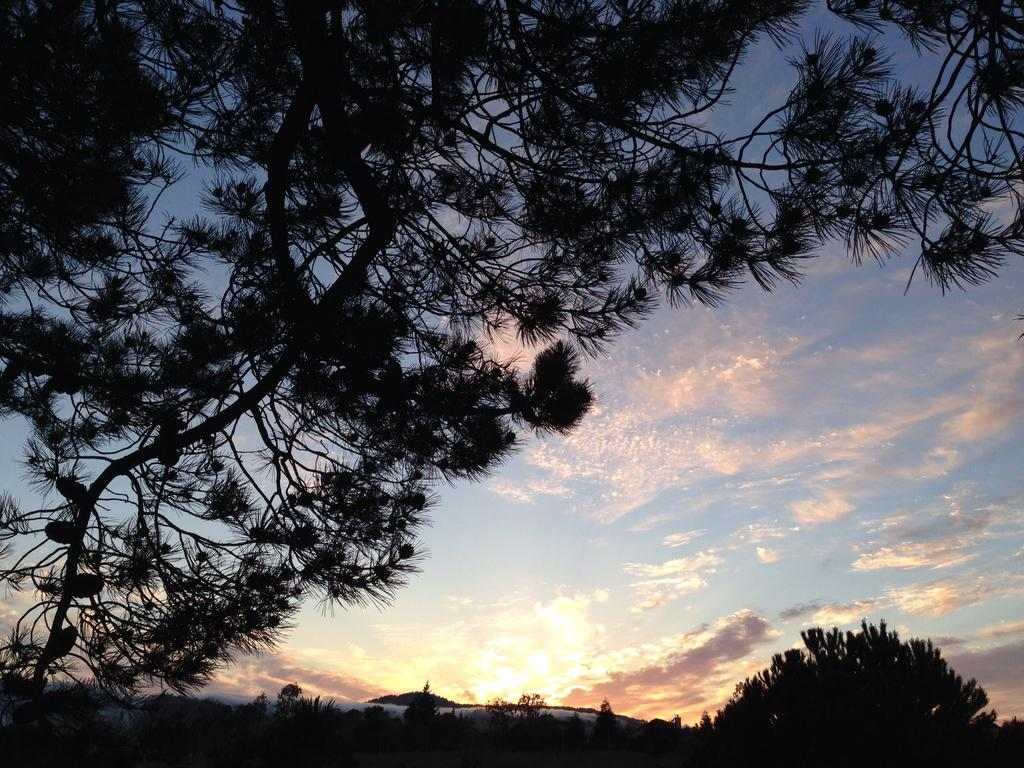What type of vegetation can be seen at the bottom of the image? There are trees at the bottom of the image. What is visible at the top of the image? The sky is visible at the top of the image. What can be seen in the sky? Clouds are present in the sky. Are there any trees on the left side of the image? Yes, there are trees on the left side of the image. Can you tell me how many memories are floating in the ocean in the image? There is no ocean or memories present in the image; it features trees and a sky with clouds. What type of copy machine is visible in the image? There is no copy machine present in the image. 